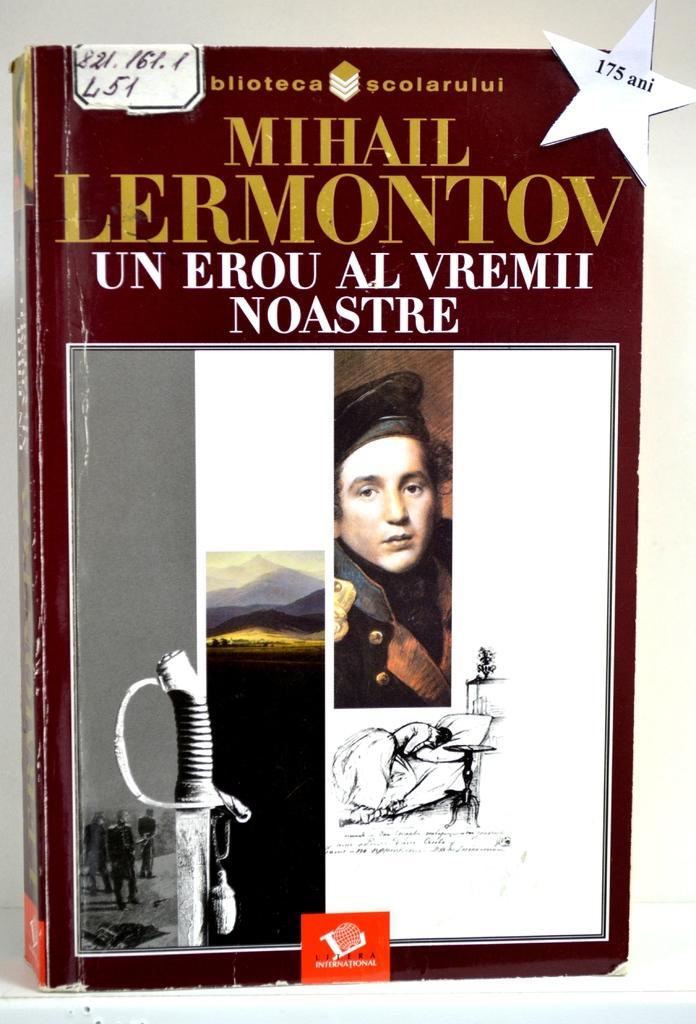How would you summarize this image in a sentence or two? In the foreground of this image, there is a book on a white surface with few images and text on it. 